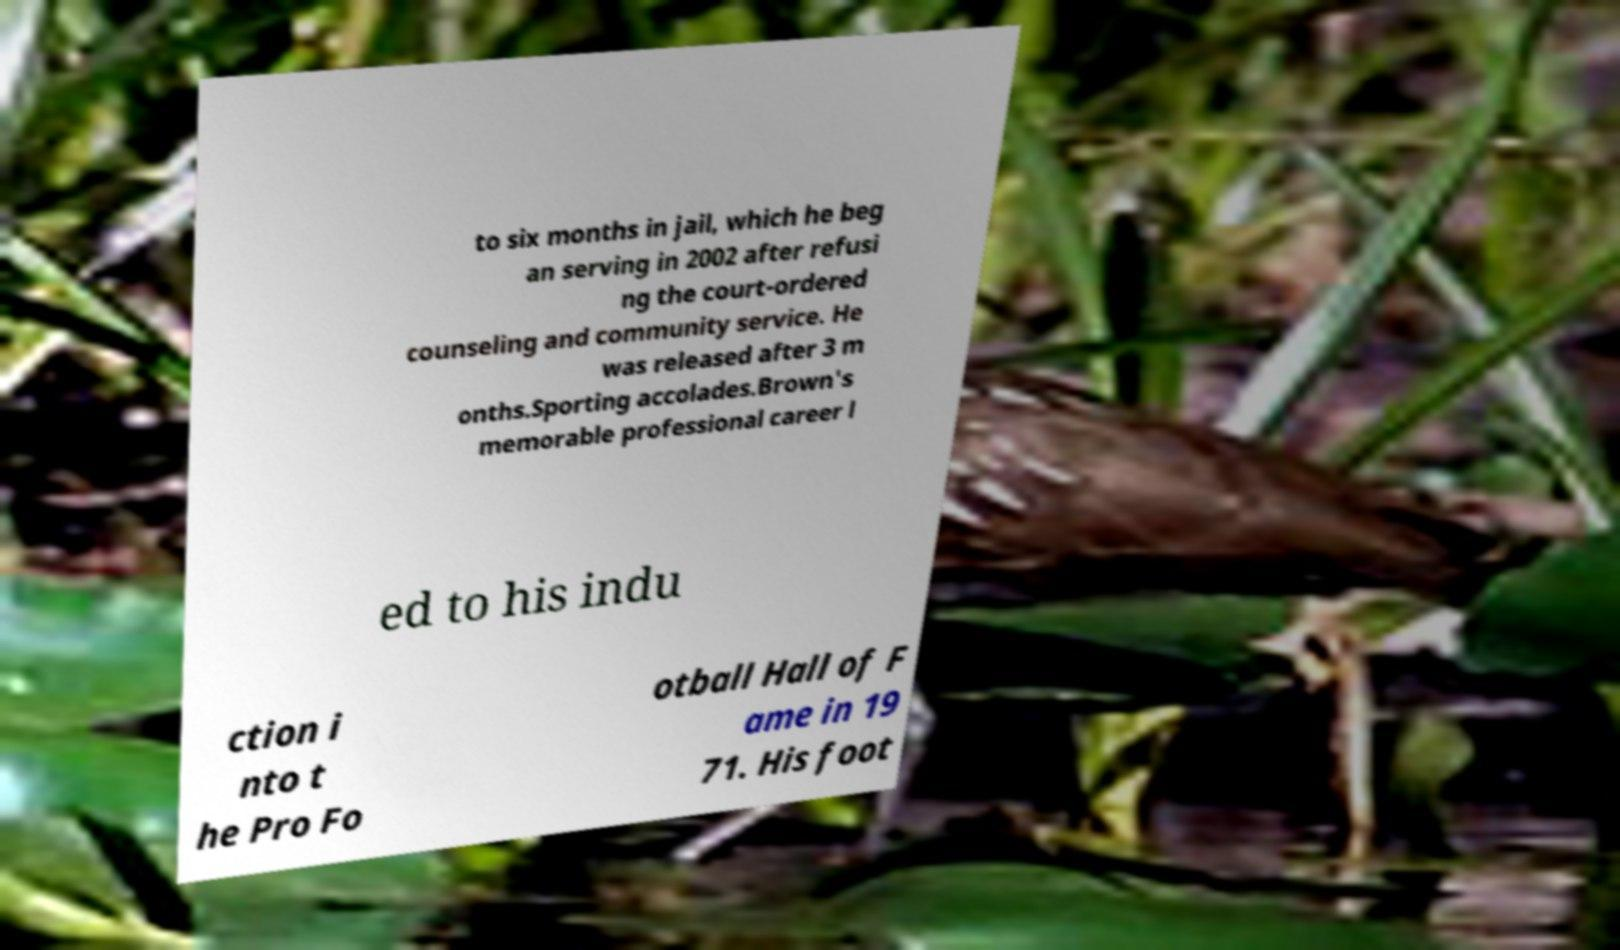Please read and relay the text visible in this image. What does it say? to six months in jail, which he beg an serving in 2002 after refusi ng the court-ordered counseling and community service. He was released after 3 m onths.Sporting accolades.Brown's memorable professional career l ed to his indu ction i nto t he Pro Fo otball Hall of F ame in 19 71. His foot 